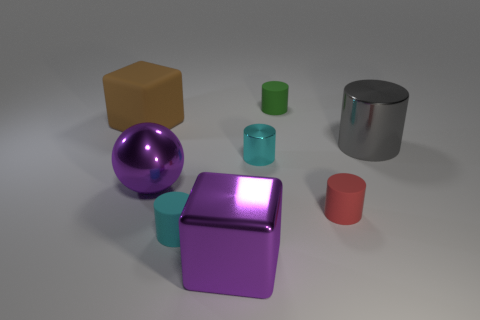What is the big thing that is in front of the cyan metal cylinder and right of the purple ball made of?
Offer a terse response. Metal. What number of other objects are there of the same size as the red rubber cylinder?
Keep it short and to the point. 3. The large matte block has what color?
Your answer should be compact. Brown. Do the small matte object behind the brown cube and the matte cylinder that is on the left side of the green object have the same color?
Your response must be concise. No. The green rubber cylinder is what size?
Offer a terse response. Small. How big is the metallic cylinder that is on the right side of the green object?
Give a very brief answer. Large. There is a object that is both behind the gray cylinder and on the left side of the cyan matte cylinder; what shape is it?
Give a very brief answer. Cube. How many other objects are the same shape as the brown matte thing?
Your answer should be compact. 1. There is a cylinder that is the same size as the metal block; what is its color?
Make the answer very short. Gray. What number of things are large purple shiny balls or tiny blue matte things?
Offer a very short reply. 1. 